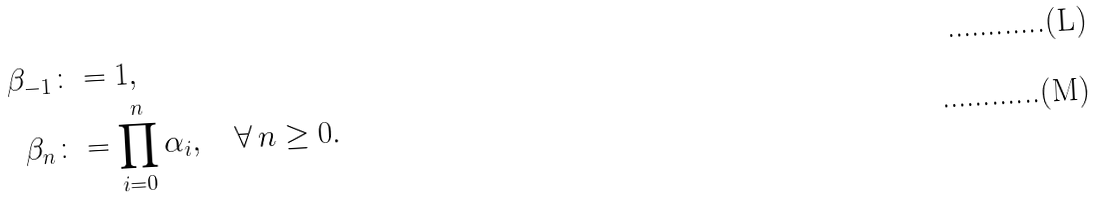<formula> <loc_0><loc_0><loc_500><loc_500>\beta _ { - 1 } & \colon = 1 , \\ \beta _ { n } & \colon = \prod _ { i = 0 } ^ { n } \alpha _ { i } , \quad \forall \, n \geq 0 .</formula> 